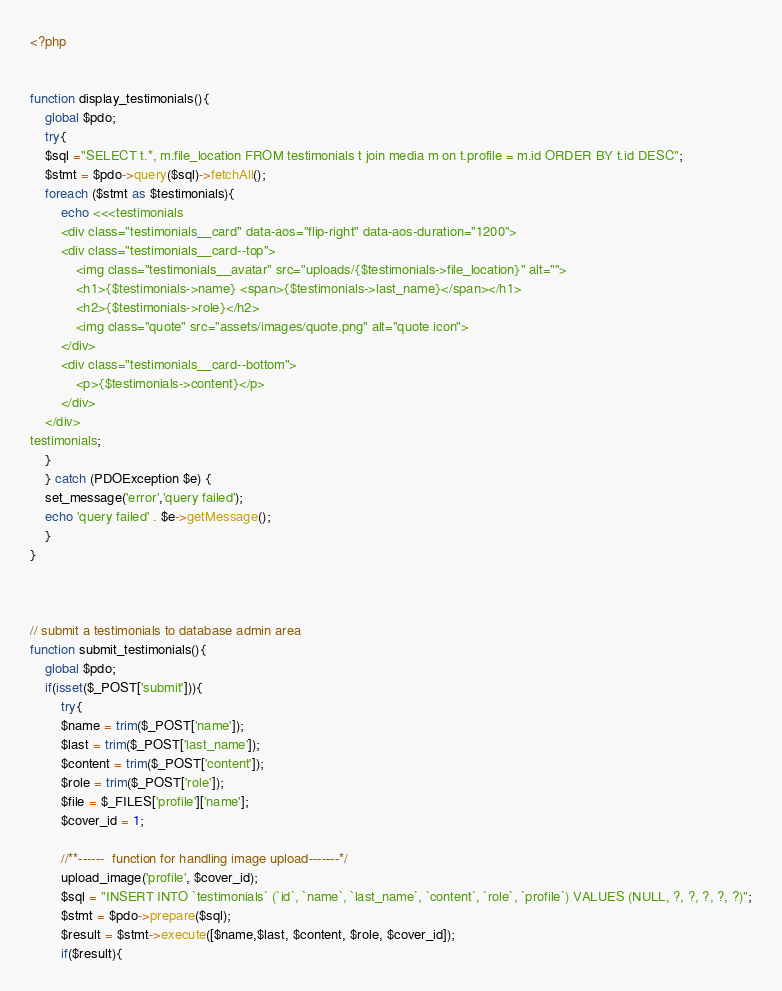Convert code to text. <code><loc_0><loc_0><loc_500><loc_500><_PHP_><?php 


function display_testimonials(){
    global $pdo;
    try{
    $sql ="SELECT t.*, m.file_location FROM testimonials t join media m on t.profile = m.id ORDER BY t.id DESC";
    $stmt = $pdo->query($sql)->fetchAll();
    foreach ($stmt as $testimonials){
        echo <<<testimonials
        <div class="testimonials__card" data-aos="flip-right" data-aos-duration="1200">
        <div class="testimonials__card--top">
            <img class="testimonials__avatar" src="uploads/{$testimonials->file_location}" alt="">
            <h1>{$testimonials->name} <span>{$testimonials->last_name}</span></h1>
            <h2>{$testimonials->role}</h2>
            <img class="quote" src="assets/images/quote.png" alt="quote icon">
        </div>
        <div class="testimonials__card--bottom">
            <p>{$testimonials->content}</p>
        </div>
    </div>
testimonials;
    }
    } catch (PDOException $e) {
    set_message('error','query failed');
    echo 'query failed' . $e->getMessage();
    }
}



// submit a testimonials to database admin area
function submit_testimonials(){
    global $pdo;
    if(isset($_POST['submit'])){
        try{
        $name = trim($_POST['name']);
        $last = trim($_POST['last_name']);
        $content = trim($_POST['content']);
        $role = trim($_POST['role']);
        $file = $_FILES['profile']['name'];
        $cover_id = 1;

        //**------  function for handling image upload-------*/
        upload_image('profile', $cover_id);
        $sql = "INSERT INTO `testimonials` (`id`, `name`, `last_name`, `content`, `role`, `profile`) VALUES (NULL, ?, ?, ?, ?, ?)";
        $stmt = $pdo->prepare($sql);
        $result = $stmt->execute([$name,$last, $content, $role, $cover_id]);
        if($result){</code> 